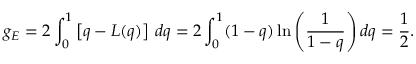<formula> <loc_0><loc_0><loc_500><loc_500>g _ { E } = 2 \int _ { 0 } ^ { 1 } \left [ q - L ( q ) \right ] \, d q = 2 \int _ { 0 } ^ { 1 } ( 1 - q ) \ln { \left ( \frac { 1 } { 1 - q } \right ) } \, d q = \frac { 1 } { 2 } .</formula> 